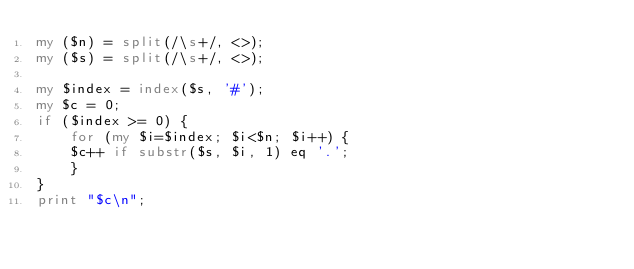<code> <loc_0><loc_0><loc_500><loc_500><_Perl_>my ($n) = split(/\s+/, <>);
my ($s) = split(/\s+/, <>);

my $index = index($s, '#');
my $c = 0;
if ($index >= 0) {
    for (my $i=$index; $i<$n; $i++) {
	$c++ if substr($s, $i, 1) eq '.';
    }
}
print "$c\n";
</code> 